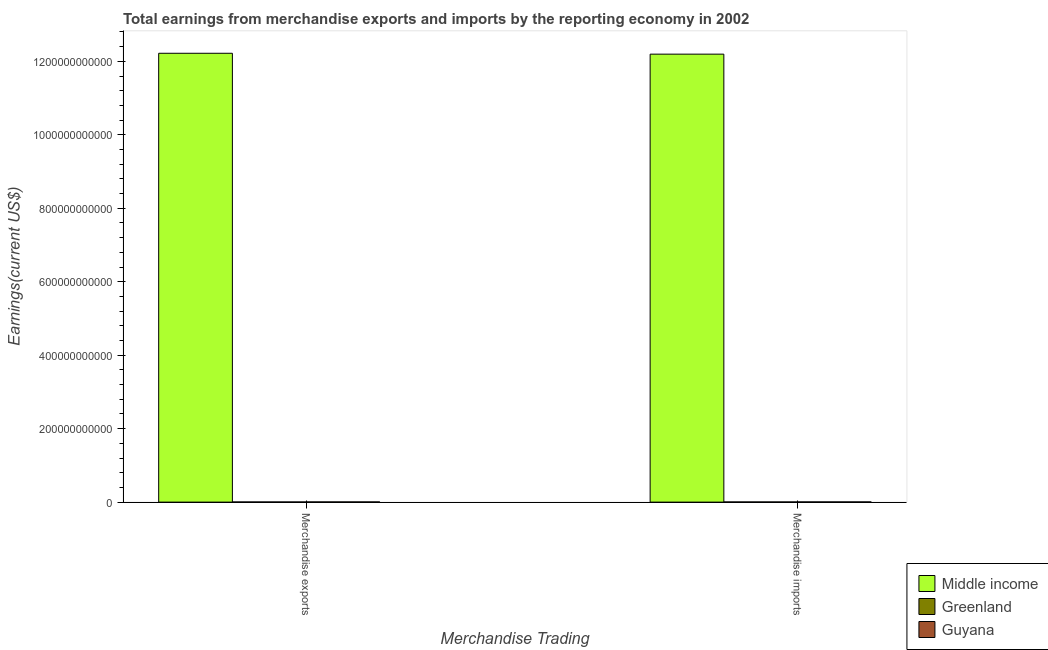How many groups of bars are there?
Make the answer very short. 2. Are the number of bars per tick equal to the number of legend labels?
Offer a very short reply. Yes. How many bars are there on the 1st tick from the left?
Keep it short and to the point. 3. How many bars are there on the 2nd tick from the right?
Provide a succinct answer. 3. What is the earnings from merchandise exports in Greenland?
Keep it short and to the point. 3.89e+08. Across all countries, what is the maximum earnings from merchandise exports?
Give a very brief answer. 1.22e+12. Across all countries, what is the minimum earnings from merchandise imports?
Your answer should be very brief. 4.44e+08. In which country was the earnings from merchandise exports minimum?
Offer a terse response. Greenland. What is the total earnings from merchandise imports in the graph?
Make the answer very short. 1.22e+12. What is the difference between the earnings from merchandise imports in Greenland and that in Middle income?
Ensure brevity in your answer.  -1.22e+12. What is the difference between the earnings from merchandise exports in Greenland and the earnings from merchandise imports in Middle income?
Your answer should be very brief. -1.22e+12. What is the average earnings from merchandise imports per country?
Ensure brevity in your answer.  4.07e+11. What is the difference between the earnings from merchandise imports and earnings from merchandise exports in Guyana?
Your response must be concise. 1.17e+07. In how many countries, is the earnings from merchandise exports greater than 280000000000 US$?
Provide a succinct answer. 1. What is the ratio of the earnings from merchandise imports in Middle income to that in Guyana?
Your response must be concise. 2195.7. What does the 1st bar from the left in Merchandise exports represents?
Give a very brief answer. Middle income. What does the 2nd bar from the right in Merchandise exports represents?
Keep it short and to the point. Greenland. How many bars are there?
Your response must be concise. 6. How many countries are there in the graph?
Provide a succinct answer. 3. What is the difference between two consecutive major ticks on the Y-axis?
Make the answer very short. 2.00e+11. Does the graph contain any zero values?
Give a very brief answer. No. Where does the legend appear in the graph?
Offer a very short reply. Bottom right. How many legend labels are there?
Offer a terse response. 3. What is the title of the graph?
Keep it short and to the point. Total earnings from merchandise exports and imports by the reporting economy in 2002. What is the label or title of the X-axis?
Provide a succinct answer. Merchandise Trading. What is the label or title of the Y-axis?
Keep it short and to the point. Earnings(current US$). What is the Earnings(current US$) in Middle income in Merchandise exports?
Keep it short and to the point. 1.22e+12. What is the Earnings(current US$) of Greenland in Merchandise exports?
Offer a very short reply. 3.89e+08. What is the Earnings(current US$) of Guyana in Merchandise exports?
Keep it short and to the point. 5.44e+08. What is the Earnings(current US$) of Middle income in Merchandise imports?
Ensure brevity in your answer.  1.22e+12. What is the Earnings(current US$) in Greenland in Merchandise imports?
Keep it short and to the point. 4.44e+08. What is the Earnings(current US$) of Guyana in Merchandise imports?
Provide a short and direct response. 5.55e+08. Across all Merchandise Trading, what is the maximum Earnings(current US$) of Middle income?
Ensure brevity in your answer.  1.22e+12. Across all Merchandise Trading, what is the maximum Earnings(current US$) of Greenland?
Ensure brevity in your answer.  4.44e+08. Across all Merchandise Trading, what is the maximum Earnings(current US$) of Guyana?
Your answer should be very brief. 5.55e+08. Across all Merchandise Trading, what is the minimum Earnings(current US$) in Middle income?
Offer a very short reply. 1.22e+12. Across all Merchandise Trading, what is the minimum Earnings(current US$) of Greenland?
Ensure brevity in your answer.  3.89e+08. Across all Merchandise Trading, what is the minimum Earnings(current US$) in Guyana?
Offer a terse response. 5.44e+08. What is the total Earnings(current US$) in Middle income in the graph?
Give a very brief answer. 2.44e+12. What is the total Earnings(current US$) in Greenland in the graph?
Give a very brief answer. 8.33e+08. What is the total Earnings(current US$) of Guyana in the graph?
Your answer should be compact. 1.10e+09. What is the difference between the Earnings(current US$) of Middle income in Merchandise exports and that in Merchandise imports?
Ensure brevity in your answer.  2.41e+09. What is the difference between the Earnings(current US$) of Greenland in Merchandise exports and that in Merchandise imports?
Your response must be concise. -5.44e+07. What is the difference between the Earnings(current US$) of Guyana in Merchandise exports and that in Merchandise imports?
Your response must be concise. -1.17e+07. What is the difference between the Earnings(current US$) in Middle income in Merchandise exports and the Earnings(current US$) in Greenland in Merchandise imports?
Offer a very short reply. 1.22e+12. What is the difference between the Earnings(current US$) of Middle income in Merchandise exports and the Earnings(current US$) of Guyana in Merchandise imports?
Give a very brief answer. 1.22e+12. What is the difference between the Earnings(current US$) in Greenland in Merchandise exports and the Earnings(current US$) in Guyana in Merchandise imports?
Your response must be concise. -1.66e+08. What is the average Earnings(current US$) of Middle income per Merchandise Trading?
Your answer should be compact. 1.22e+12. What is the average Earnings(current US$) of Greenland per Merchandise Trading?
Give a very brief answer. 4.17e+08. What is the average Earnings(current US$) in Guyana per Merchandise Trading?
Offer a very short reply. 5.50e+08. What is the difference between the Earnings(current US$) of Middle income and Earnings(current US$) of Greenland in Merchandise exports?
Ensure brevity in your answer.  1.22e+12. What is the difference between the Earnings(current US$) in Middle income and Earnings(current US$) in Guyana in Merchandise exports?
Make the answer very short. 1.22e+12. What is the difference between the Earnings(current US$) of Greenland and Earnings(current US$) of Guyana in Merchandise exports?
Your response must be concise. -1.54e+08. What is the difference between the Earnings(current US$) in Middle income and Earnings(current US$) in Greenland in Merchandise imports?
Offer a very short reply. 1.22e+12. What is the difference between the Earnings(current US$) of Middle income and Earnings(current US$) of Guyana in Merchandise imports?
Ensure brevity in your answer.  1.22e+12. What is the difference between the Earnings(current US$) of Greenland and Earnings(current US$) of Guyana in Merchandise imports?
Provide a short and direct response. -1.12e+08. What is the ratio of the Earnings(current US$) of Middle income in Merchandise exports to that in Merchandise imports?
Give a very brief answer. 1. What is the ratio of the Earnings(current US$) in Greenland in Merchandise exports to that in Merchandise imports?
Offer a very short reply. 0.88. What is the ratio of the Earnings(current US$) of Guyana in Merchandise exports to that in Merchandise imports?
Provide a succinct answer. 0.98. What is the difference between the highest and the second highest Earnings(current US$) of Middle income?
Offer a very short reply. 2.41e+09. What is the difference between the highest and the second highest Earnings(current US$) of Greenland?
Provide a short and direct response. 5.44e+07. What is the difference between the highest and the second highest Earnings(current US$) of Guyana?
Offer a very short reply. 1.17e+07. What is the difference between the highest and the lowest Earnings(current US$) of Middle income?
Your answer should be very brief. 2.41e+09. What is the difference between the highest and the lowest Earnings(current US$) in Greenland?
Provide a succinct answer. 5.44e+07. What is the difference between the highest and the lowest Earnings(current US$) of Guyana?
Your answer should be compact. 1.17e+07. 